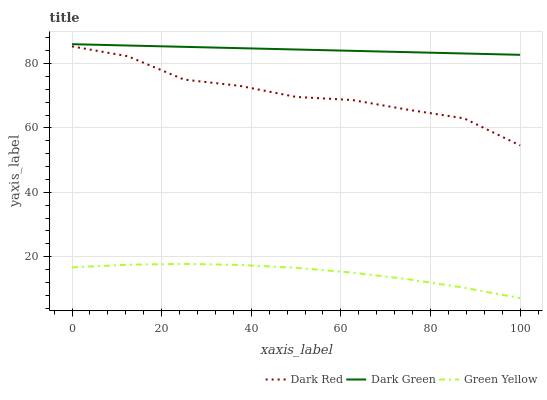Does Green Yellow have the minimum area under the curve?
Answer yes or no. Yes. Does Dark Green have the maximum area under the curve?
Answer yes or no. Yes. Does Dark Green have the minimum area under the curve?
Answer yes or no. No. Does Green Yellow have the maximum area under the curve?
Answer yes or no. No. Is Dark Green the smoothest?
Answer yes or no. Yes. Is Dark Red the roughest?
Answer yes or no. Yes. Is Green Yellow the smoothest?
Answer yes or no. No. Is Green Yellow the roughest?
Answer yes or no. No. Does Green Yellow have the lowest value?
Answer yes or no. Yes. Does Dark Green have the lowest value?
Answer yes or no. No. Does Dark Green have the highest value?
Answer yes or no. Yes. Does Green Yellow have the highest value?
Answer yes or no. No. Is Green Yellow less than Dark Green?
Answer yes or no. Yes. Is Dark Green greater than Green Yellow?
Answer yes or no. Yes. Does Green Yellow intersect Dark Green?
Answer yes or no. No. 